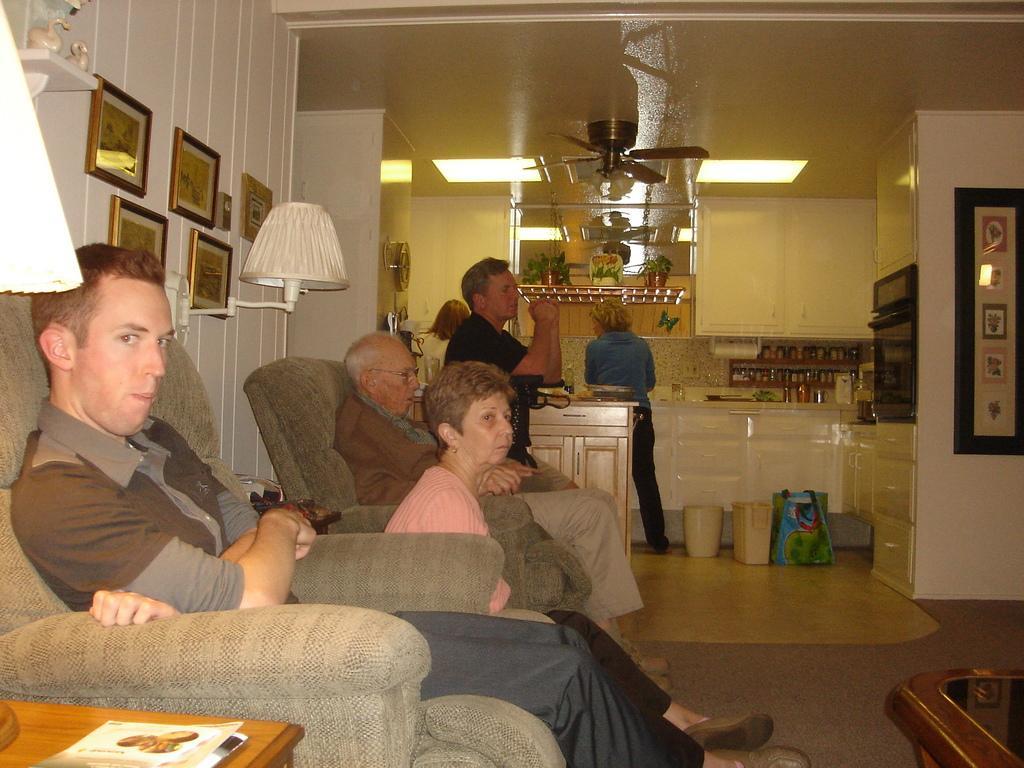Can you describe this image briefly? In this picture we can see six people, tables, book, lamps, cupboards, bag, jars, lights, fan, house plants, frames on walls and three people are sitting on chairs and some objects. 